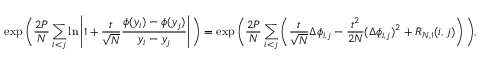<formula> <loc_0><loc_0><loc_500><loc_500>\exp \left ( \frac { 2 P } { N } \sum _ { i < j } \ln \left | 1 + \frac { t } { \sqrt { N } } \frac { \phi ( y _ { i } ) - \phi ( y _ { j } ) } { y _ { i } - y _ { j } } \right | \right ) = \exp \left ( \frac { 2 P } { N } \sum _ { i < j } \left ( \frac { t } { \sqrt { N } } \Delta \phi _ { i , j } - \frac { t ^ { 2 } } { 2 N } ( \Delta \phi _ { i , j } ) ^ { 2 } + R _ { N , 1 } ( i , j ) \right ) \right ) ,</formula> 